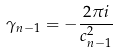Convert formula to latex. <formula><loc_0><loc_0><loc_500><loc_500>\gamma _ { n - 1 } = - \frac { 2 \pi i } { c ^ { 2 } _ { n - 1 } }</formula> 